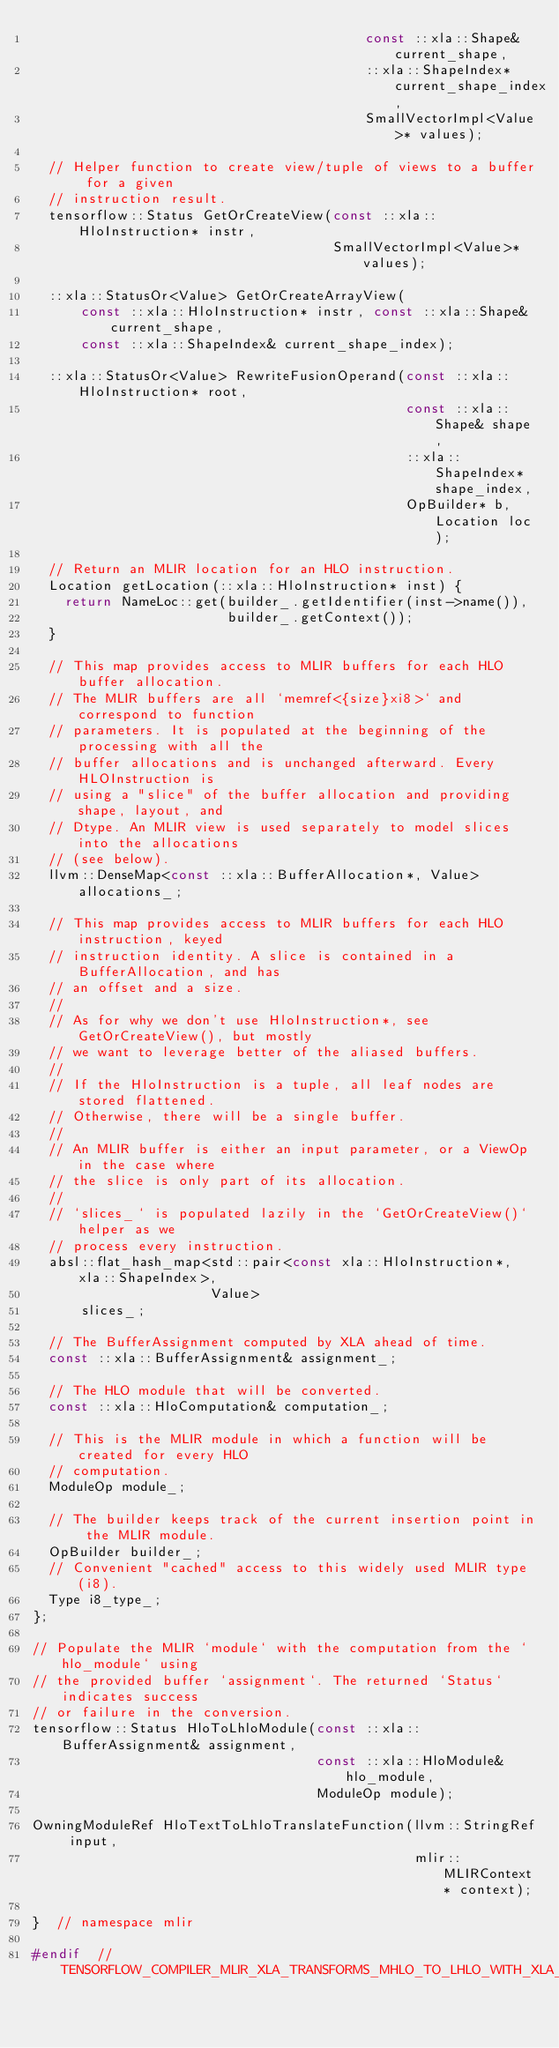Convert code to text. <code><loc_0><loc_0><loc_500><loc_500><_C_>                                         const ::xla::Shape& current_shape,
                                         ::xla::ShapeIndex* current_shape_index,
                                         SmallVectorImpl<Value>* values);

  // Helper function to create view/tuple of views to a buffer for a given
  // instruction result.
  tensorflow::Status GetOrCreateView(const ::xla::HloInstruction* instr,
                                     SmallVectorImpl<Value>* values);

  ::xla::StatusOr<Value> GetOrCreateArrayView(
      const ::xla::HloInstruction* instr, const ::xla::Shape& current_shape,
      const ::xla::ShapeIndex& current_shape_index);

  ::xla::StatusOr<Value> RewriteFusionOperand(const ::xla::HloInstruction* root,
                                              const ::xla::Shape& shape,
                                              ::xla::ShapeIndex* shape_index,
                                              OpBuilder* b, Location loc);

  // Return an MLIR location for an HLO instruction.
  Location getLocation(::xla::HloInstruction* inst) {
    return NameLoc::get(builder_.getIdentifier(inst->name()),
                        builder_.getContext());
  }

  // This map provides access to MLIR buffers for each HLO buffer allocation.
  // The MLIR buffers are all `memref<{size}xi8>` and correspond to function
  // parameters. It is populated at the beginning of the processing with all the
  // buffer allocations and is unchanged afterward. Every HLOInstruction is
  // using a "slice" of the buffer allocation and providing shape, layout, and
  // Dtype. An MLIR view is used separately to model slices into the allocations
  // (see below).
  llvm::DenseMap<const ::xla::BufferAllocation*, Value> allocations_;

  // This map provides access to MLIR buffers for each HLO instruction, keyed
  // instruction identity. A slice is contained in a BufferAllocation, and has
  // an offset and a size.
  //
  // As for why we don't use HloInstruction*, see GetOrCreateView(), but mostly
  // we want to leverage better of the aliased buffers.
  //
  // If the HloInstruction is a tuple, all leaf nodes are stored flattened.
  // Otherwise, there will be a single buffer.
  //
  // An MLIR buffer is either an input parameter, or a ViewOp in the case where
  // the slice is only part of its allocation.
  //
  // `slices_` is populated lazily in the `GetOrCreateView()` helper as we
  // process every instruction.
  absl::flat_hash_map<std::pair<const xla::HloInstruction*, xla::ShapeIndex>,
                      Value>
      slices_;

  // The BufferAssignment computed by XLA ahead of time.
  const ::xla::BufferAssignment& assignment_;

  // The HLO module that will be converted.
  const ::xla::HloComputation& computation_;

  // This is the MLIR module in which a function will be created for every HLO
  // computation.
  ModuleOp module_;

  // The builder keeps track of the current insertion point in the MLIR module.
  OpBuilder builder_;
  // Convenient "cached" access to this widely used MLIR type (i8).
  Type i8_type_;
};

// Populate the MLIR `module` with the computation from the `hlo_module` using
// the provided buffer `assignment`. The returned `Status` indicates success
// or failure in the conversion.
tensorflow::Status HloToLhloModule(const ::xla::BufferAssignment& assignment,
                                   const ::xla::HloModule& hlo_module,
                                   ModuleOp module);

OwningModuleRef HloTextToLhloTranslateFunction(llvm::StringRef input,
                                               mlir::MLIRContext* context);

}  // namespace mlir

#endif  // TENSORFLOW_COMPILER_MLIR_XLA_TRANSFORMS_MHLO_TO_LHLO_WITH_XLA_H_
</code> 